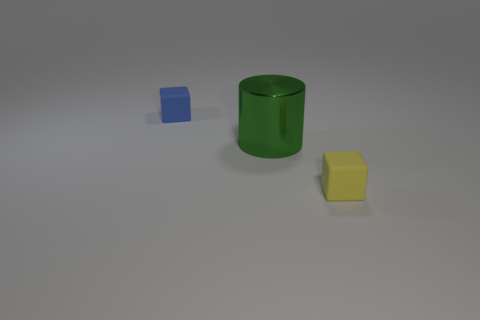Add 1 large green matte cubes. How many objects exist? 4 Subtract all cubes. How many objects are left? 1 Subtract 0 yellow balls. How many objects are left? 3 Subtract all tiny gray metal cubes. Subtract all small rubber objects. How many objects are left? 1 Add 2 rubber things. How many rubber things are left? 4 Add 1 big red rubber blocks. How many big red rubber blocks exist? 1 